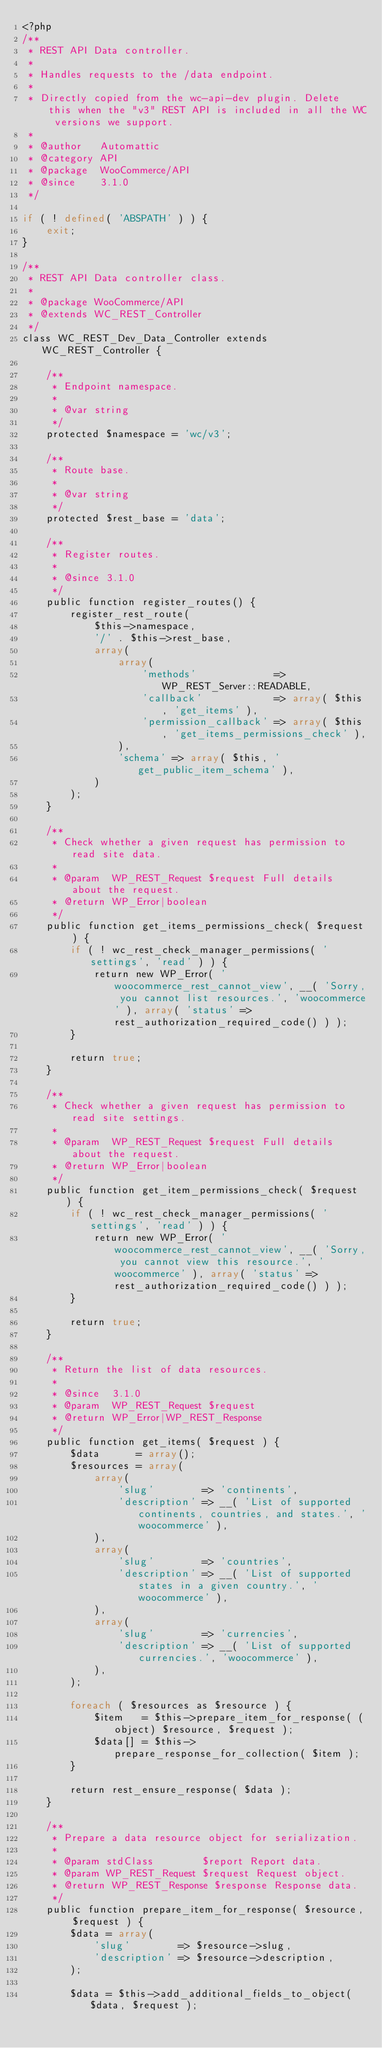<code> <loc_0><loc_0><loc_500><loc_500><_PHP_><?php
/**
 * REST API Data controller.
 *
 * Handles requests to the /data endpoint.
 *
 * Directly copied from the wc-api-dev plugin. Delete this when the "v3" REST API is included in all the WC versions we support.
 *
 * @author   Automattic
 * @category API
 * @package  WooCommerce/API
 * @since    3.1.0
 */

if ( ! defined( 'ABSPATH' ) ) {
	exit;
}

/**
 * REST API Data controller class.
 *
 * @package WooCommerce/API
 * @extends WC_REST_Controller
 */
class WC_REST_Dev_Data_Controller extends WC_REST_Controller {

	/**
	 * Endpoint namespace.
	 *
	 * @var string
	 */
	protected $namespace = 'wc/v3';

	/**
	 * Route base.
	 *
	 * @var string
	 */
	protected $rest_base = 'data';

	/**
	 * Register routes.
	 *
	 * @since 3.1.0
	 */
	public function register_routes() {
		register_rest_route(
			$this->namespace,
			'/' . $this->rest_base,
			array(
				array(
					'methods'             => WP_REST_Server::READABLE,
					'callback'            => array( $this, 'get_items' ),
					'permission_callback' => array( $this, 'get_items_permissions_check' ),
				),
				'schema' => array( $this, 'get_public_item_schema' ),
			)
		);
	}

	/**
	 * Check whether a given request has permission to read site data.
	 *
	 * @param  WP_REST_Request $request Full details about the request.
	 * @return WP_Error|boolean
	 */
	public function get_items_permissions_check( $request ) {
		if ( ! wc_rest_check_manager_permissions( 'settings', 'read' ) ) {
			return new WP_Error( 'woocommerce_rest_cannot_view', __( 'Sorry, you cannot list resources.', 'woocommerce' ), array( 'status' => rest_authorization_required_code() ) );
		}

		return true;
	}

	/**
	 * Check whether a given request has permission to read site settings.
	 *
	 * @param  WP_REST_Request $request Full details about the request.
	 * @return WP_Error|boolean
	 */
	public function get_item_permissions_check( $request ) {
		if ( ! wc_rest_check_manager_permissions( 'settings', 'read' ) ) {
			return new WP_Error( 'woocommerce_rest_cannot_view', __( 'Sorry, you cannot view this resource.', 'woocommerce' ), array( 'status' => rest_authorization_required_code() ) );
		}

		return true;
	}

	/**
	 * Return the list of data resources.
	 *
	 * @since  3.1.0
	 * @param  WP_REST_Request $request
	 * @return WP_Error|WP_REST_Response
	 */
	public function get_items( $request ) {
		$data      = array();
		$resources = array(
			array(
				'slug'        => 'continents',
				'description' => __( 'List of supported continents, countries, and states.', 'woocommerce' ),
			),
			array(
				'slug'        => 'countries',
				'description' => __( 'List of supported states in a given country.', 'woocommerce' ),
			),
			array(
				'slug'        => 'currencies',
				'description' => __( 'List of supported currencies.', 'woocommerce' ),
			),
		);

		foreach ( $resources as $resource ) {
			$item   = $this->prepare_item_for_response( (object) $resource, $request );
			$data[] = $this->prepare_response_for_collection( $item );
		}

		return rest_ensure_response( $data );
	}

	/**
	 * Prepare a data resource object for serialization.
	 *
	 * @param stdClass        $report Report data.
	 * @param WP_REST_Request $request Request object.
	 * @return WP_REST_Response $response Response data.
	 */
	public function prepare_item_for_response( $resource, $request ) {
		$data = array(
			'slug'        => $resource->slug,
			'description' => $resource->description,
		);

		$data = $this->add_additional_fields_to_object( $data, $request );</code> 